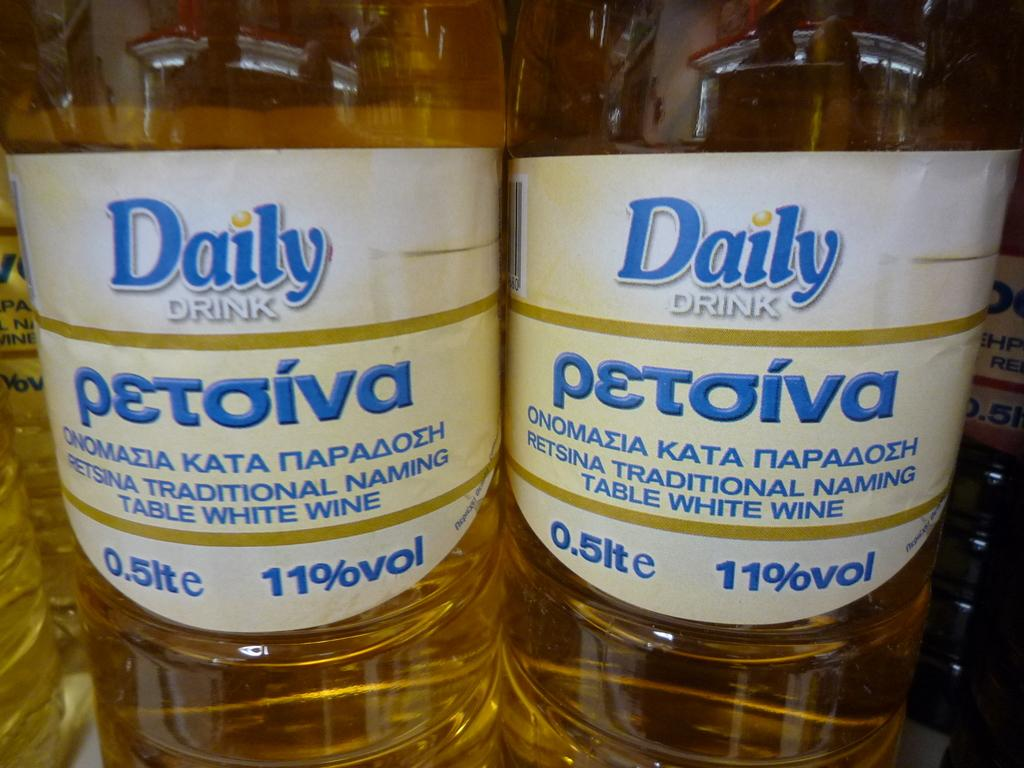<image>
Describe the image concisely. Two bottles have white labels with the Daily Drink logo on them. 